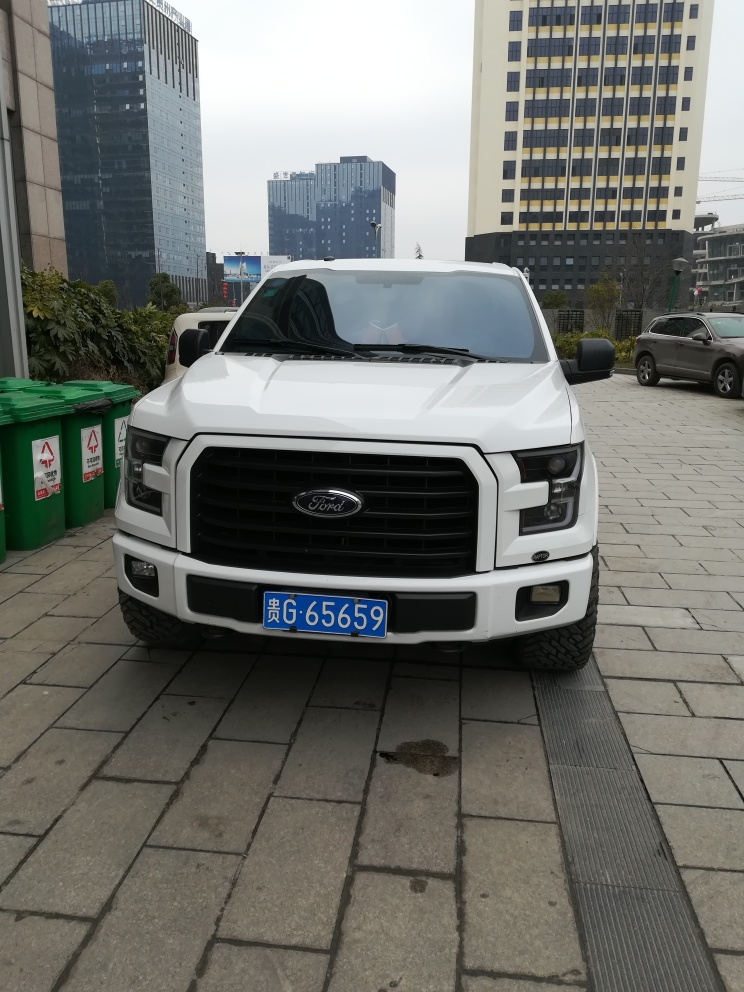What does the setting tell us about the location where the photo was taken? The photo was taken in an urban environment, as evidenced by the high-rise buildings in the background. The tidy paving and planter boxes suggest an organized city space, possibly a commercial district. Are there any cultural or regional indicators visible? The license plate on the vehicle has a blue strip at the top, which is a characteristic of Chinese vehicle registration plates. This indicates that the photo was likely taken in China. 